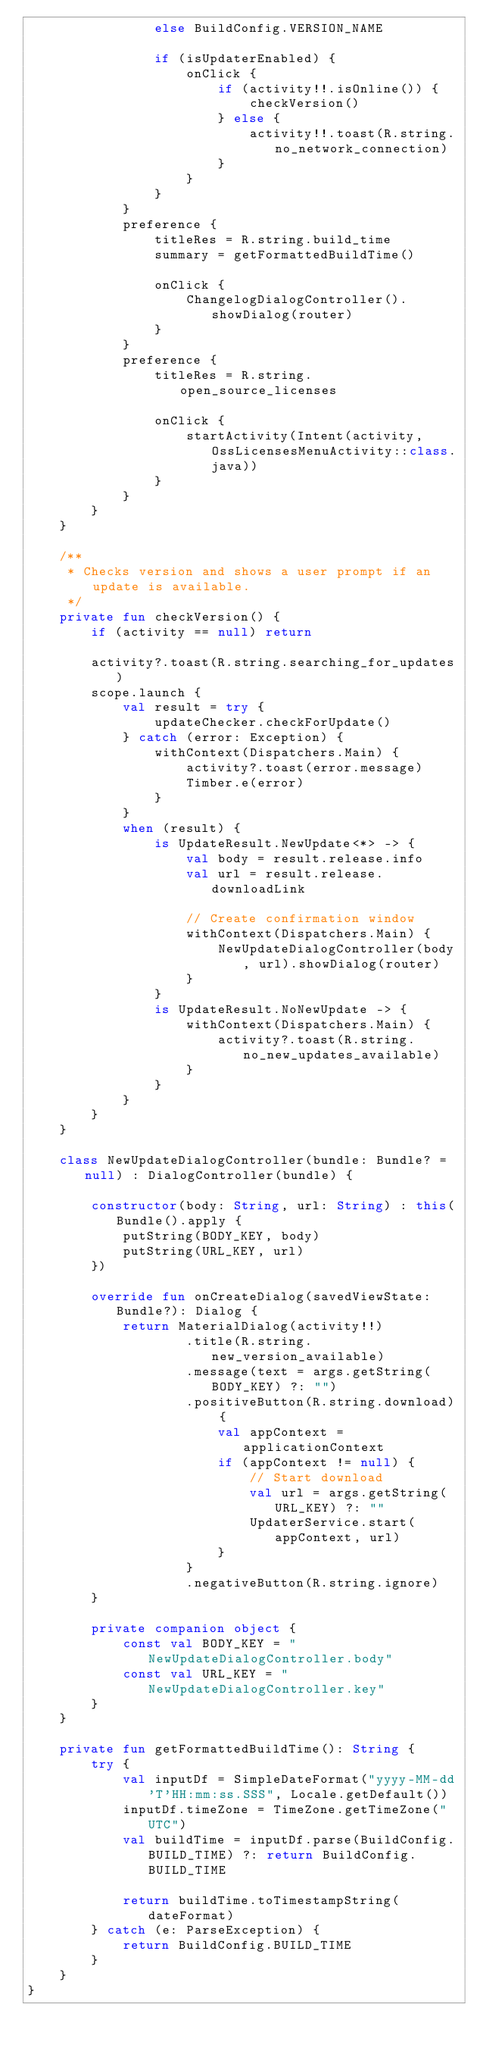Convert code to text. <code><loc_0><loc_0><loc_500><loc_500><_Kotlin_>                else BuildConfig.VERSION_NAME

                if (isUpdaterEnabled) {
                    onClick {
                        if (activity!!.isOnline()) {
                            checkVersion()
                        } else {
                            activity!!.toast(R.string.no_network_connection)
                        }
                    }
                }
            }
            preference {
                titleRes = R.string.build_time
                summary = getFormattedBuildTime()

                onClick {
                    ChangelogDialogController().showDialog(router)
                }
            }
            preference {
                titleRes = R.string.open_source_licenses

                onClick {
                    startActivity(Intent(activity, OssLicensesMenuActivity::class.java))
                }
            }
        }
    }

    /**
     * Checks version and shows a user prompt if an update is available.
     */
    private fun checkVersion() {
        if (activity == null) return

        activity?.toast(R.string.searching_for_updates)
        scope.launch {
            val result = try {
                updateChecker.checkForUpdate()
            } catch (error: Exception) {
                withContext(Dispatchers.Main) {
                    activity?.toast(error.message)
                    Timber.e(error)
                }
            }
            when (result) {
                is UpdateResult.NewUpdate<*> -> {
                    val body = result.release.info
                    val url = result.release.downloadLink

                    // Create confirmation window
                    withContext(Dispatchers.Main) {
                        NewUpdateDialogController(body, url).showDialog(router)
                    }
                }
                is UpdateResult.NoNewUpdate -> {
                    withContext(Dispatchers.Main) {
                        activity?.toast(R.string.no_new_updates_available)
                    }
                }
            }
        }
    }

    class NewUpdateDialogController(bundle: Bundle? = null) : DialogController(bundle) {

        constructor(body: String, url: String) : this(Bundle().apply {
            putString(BODY_KEY, body)
            putString(URL_KEY, url)
        })

        override fun onCreateDialog(savedViewState: Bundle?): Dialog {
            return MaterialDialog(activity!!)
                    .title(R.string.new_version_available)
                    .message(text = args.getString(BODY_KEY) ?: "")
                    .positiveButton(R.string.download) {
                        val appContext = applicationContext
                        if (appContext != null) {
                            // Start download
                            val url = args.getString(URL_KEY) ?: ""
                            UpdaterService.start(appContext, url)
                        }
                    }
                    .negativeButton(R.string.ignore)
        }

        private companion object {
            const val BODY_KEY = "NewUpdateDialogController.body"
            const val URL_KEY = "NewUpdateDialogController.key"
        }
    }

    private fun getFormattedBuildTime(): String {
        try {
            val inputDf = SimpleDateFormat("yyyy-MM-dd'T'HH:mm:ss.SSS", Locale.getDefault())
            inputDf.timeZone = TimeZone.getTimeZone("UTC")
            val buildTime = inputDf.parse(BuildConfig.BUILD_TIME) ?: return BuildConfig.BUILD_TIME

            return buildTime.toTimestampString(dateFormat)
        } catch (e: ParseException) {
            return BuildConfig.BUILD_TIME
        }
    }
}
</code> 